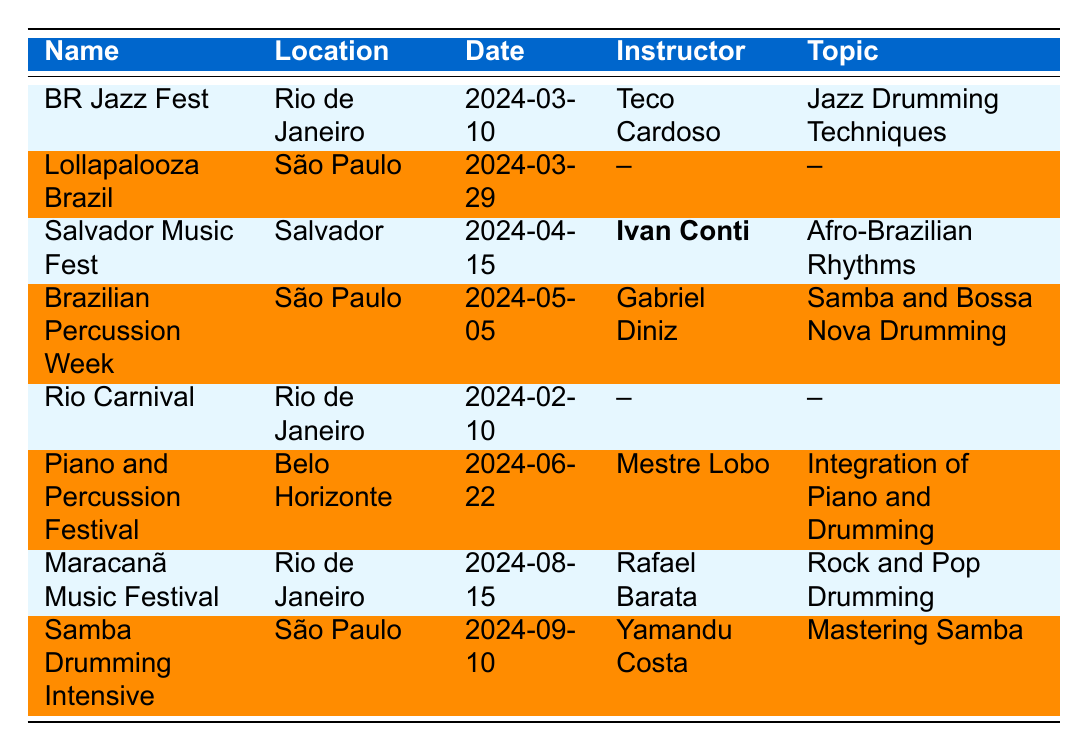What is the date of the BR Jazz Fest? The table shows that the BR Jazz Fest is scheduled for March 10, 2024.
Answer: March 10, 2024 Which festival features a workshop led by Ivan Conti? The Salvador Music Fest includes a drumming workshop where Ivan Conti is the instructor.
Answer: Salvador Music Fest How many festivals are taking place in São Paulo? There are three festivals listed in the table that are taking place in São Paulo: Lollapalooza Brazil, Brazilian Percussion Week, and Samba Drumming Intensive.
Answer: Three Is there a drumming workshop at the Rio Carnival? The table states that the Rio Carnival does not have a drumming workshop listed.
Answer: No Which festival has the latest date? The latest festival date is August 15, 2024, which is for the Maracanã Music Festival.
Answer: Maracanã Music Festival Count the number of drumming workshops scheduled. There are five workshops indicated in the table: BR Jazz Fest, Salvador Music Fest, Brazilian Percussion Week, Piano and Percussion Festival, Maracanã Music Festival, and Samba Drumming Intensive, making a total of six workshops.
Answer: Six What is the topic of the workshop at the Piano and Percussion Festival? The topic of the workshop at the Piano and Percussion Festival is "Integration of Piano and Drumming."
Answer: Integration of Piano and Drumming Which festival focuses on Afro-Brazilian rhythms? The Salvador Music Fest focuses specifically on Afro-Brazilian rhythms and cultural expressions.
Answer: Salvador Music Fest How many instructors are mentioned in the table? The table lists five different instructors for the drumming workshops: Teco Cardoso, Ivan Conti, Gabriel Diniz, Mestre Lobo, Rafael Barata, and Yamandu Costa, totaling six.
Answer: Six 